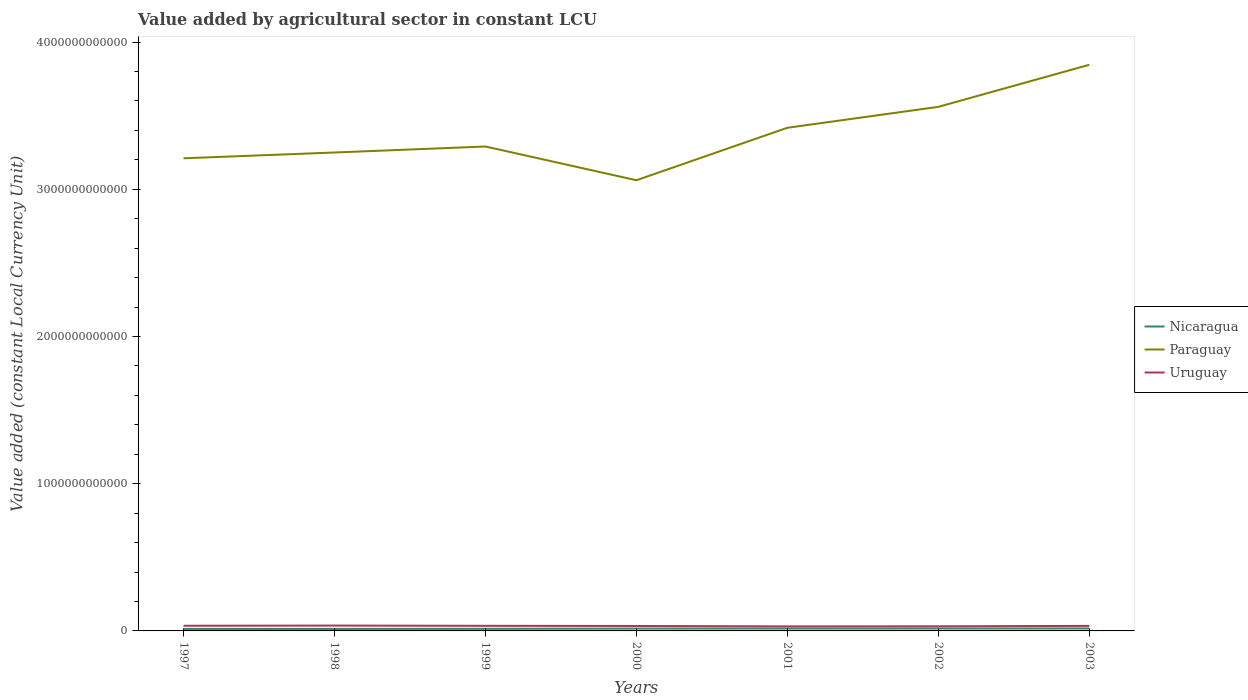How many different coloured lines are there?
Offer a very short reply. 3. Does the line corresponding to Uruguay intersect with the line corresponding to Nicaragua?
Provide a succinct answer. No. Across all years, what is the maximum value added by agricultural sector in Paraguay?
Ensure brevity in your answer.  3.06e+12. In which year was the value added by agricultural sector in Paraguay maximum?
Ensure brevity in your answer.  2000. What is the total value added by agricultural sector in Nicaragua in the graph?
Ensure brevity in your answer.  -3.24e+09. What is the difference between the highest and the second highest value added by agricultural sector in Paraguay?
Offer a terse response. 7.84e+11. How many lines are there?
Give a very brief answer. 3. How many years are there in the graph?
Ensure brevity in your answer.  7. What is the difference between two consecutive major ticks on the Y-axis?
Your answer should be compact. 1.00e+12. Does the graph contain grids?
Your answer should be compact. No. Where does the legend appear in the graph?
Make the answer very short. Center right. What is the title of the graph?
Make the answer very short. Value added by agricultural sector in constant LCU. What is the label or title of the X-axis?
Provide a succinct answer. Years. What is the label or title of the Y-axis?
Your answer should be very brief. Value added (constant Local Currency Unit). What is the Value added (constant Local Currency Unit) of Nicaragua in 1997?
Make the answer very short. 1.35e+1. What is the Value added (constant Local Currency Unit) of Paraguay in 1997?
Offer a very short reply. 3.21e+12. What is the Value added (constant Local Currency Unit) in Uruguay in 1997?
Ensure brevity in your answer.  3.51e+1. What is the Value added (constant Local Currency Unit) in Nicaragua in 1998?
Offer a very short reply. 1.34e+1. What is the Value added (constant Local Currency Unit) in Paraguay in 1998?
Keep it short and to the point. 3.25e+12. What is the Value added (constant Local Currency Unit) in Uruguay in 1998?
Provide a short and direct response. 3.64e+1. What is the Value added (constant Local Currency Unit) in Nicaragua in 1999?
Your answer should be compact. 1.42e+1. What is the Value added (constant Local Currency Unit) in Paraguay in 1999?
Keep it short and to the point. 3.29e+12. What is the Value added (constant Local Currency Unit) of Uruguay in 1999?
Provide a succinct answer. 3.47e+1. What is the Value added (constant Local Currency Unit) of Nicaragua in 2000?
Make the answer very short. 1.60e+1. What is the Value added (constant Local Currency Unit) in Paraguay in 2000?
Keep it short and to the point. 3.06e+12. What is the Value added (constant Local Currency Unit) of Uruguay in 2000?
Give a very brief answer. 3.36e+1. What is the Value added (constant Local Currency Unit) in Nicaragua in 2001?
Your answer should be very brief. 1.64e+1. What is the Value added (constant Local Currency Unit) in Paraguay in 2001?
Give a very brief answer. 3.42e+12. What is the Value added (constant Local Currency Unit) of Uruguay in 2001?
Your answer should be very brief. 3.07e+1. What is the Value added (constant Local Currency Unit) in Nicaragua in 2002?
Your response must be concise. 1.63e+1. What is the Value added (constant Local Currency Unit) in Paraguay in 2002?
Offer a very short reply. 3.56e+12. What is the Value added (constant Local Currency Unit) of Uruguay in 2002?
Your response must be concise. 3.13e+1. What is the Value added (constant Local Currency Unit) of Nicaragua in 2003?
Offer a very short reply. 1.67e+1. What is the Value added (constant Local Currency Unit) in Paraguay in 2003?
Offer a very short reply. 3.85e+12. What is the Value added (constant Local Currency Unit) of Uruguay in 2003?
Give a very brief answer. 3.41e+1. Across all years, what is the maximum Value added (constant Local Currency Unit) of Nicaragua?
Provide a short and direct response. 1.67e+1. Across all years, what is the maximum Value added (constant Local Currency Unit) of Paraguay?
Your answer should be compact. 3.85e+12. Across all years, what is the maximum Value added (constant Local Currency Unit) in Uruguay?
Offer a terse response. 3.64e+1. Across all years, what is the minimum Value added (constant Local Currency Unit) in Nicaragua?
Provide a short and direct response. 1.34e+1. Across all years, what is the minimum Value added (constant Local Currency Unit) in Paraguay?
Your answer should be compact. 3.06e+12. Across all years, what is the minimum Value added (constant Local Currency Unit) in Uruguay?
Make the answer very short. 3.07e+1. What is the total Value added (constant Local Currency Unit) in Nicaragua in the graph?
Offer a very short reply. 1.06e+11. What is the total Value added (constant Local Currency Unit) of Paraguay in the graph?
Keep it short and to the point. 2.36e+13. What is the total Value added (constant Local Currency Unit) in Uruguay in the graph?
Keep it short and to the point. 2.36e+11. What is the difference between the Value added (constant Local Currency Unit) of Nicaragua in 1997 and that in 1998?
Provide a short and direct response. 3.58e+07. What is the difference between the Value added (constant Local Currency Unit) of Paraguay in 1997 and that in 1998?
Make the answer very short. -3.94e+1. What is the difference between the Value added (constant Local Currency Unit) of Uruguay in 1997 and that in 1998?
Give a very brief answer. -1.32e+09. What is the difference between the Value added (constant Local Currency Unit) in Nicaragua in 1997 and that in 1999?
Ensure brevity in your answer.  -7.79e+08. What is the difference between the Value added (constant Local Currency Unit) in Paraguay in 1997 and that in 1999?
Make the answer very short. -8.01e+1. What is the difference between the Value added (constant Local Currency Unit) in Uruguay in 1997 and that in 1999?
Your answer should be very brief. 3.58e+08. What is the difference between the Value added (constant Local Currency Unit) of Nicaragua in 1997 and that in 2000?
Make the answer very short. -2.50e+09. What is the difference between the Value added (constant Local Currency Unit) in Paraguay in 1997 and that in 2000?
Keep it short and to the point. 1.49e+11. What is the difference between the Value added (constant Local Currency Unit) in Uruguay in 1997 and that in 2000?
Give a very brief answer. 1.50e+09. What is the difference between the Value added (constant Local Currency Unit) in Nicaragua in 1997 and that in 2001?
Your answer should be compact. -2.92e+09. What is the difference between the Value added (constant Local Currency Unit) in Paraguay in 1997 and that in 2001?
Your answer should be compact. -2.07e+11. What is the difference between the Value added (constant Local Currency Unit) of Uruguay in 1997 and that in 2001?
Ensure brevity in your answer.  4.37e+09. What is the difference between the Value added (constant Local Currency Unit) in Nicaragua in 1997 and that in 2002?
Offer a terse response. -2.88e+09. What is the difference between the Value added (constant Local Currency Unit) of Paraguay in 1997 and that in 2002?
Your answer should be very brief. -3.49e+11. What is the difference between the Value added (constant Local Currency Unit) in Uruguay in 1997 and that in 2002?
Your answer should be compact. 3.76e+09. What is the difference between the Value added (constant Local Currency Unit) of Nicaragua in 1997 and that in 2003?
Your response must be concise. -3.20e+09. What is the difference between the Value added (constant Local Currency Unit) in Paraguay in 1997 and that in 2003?
Ensure brevity in your answer.  -6.35e+11. What is the difference between the Value added (constant Local Currency Unit) in Uruguay in 1997 and that in 2003?
Your answer should be compact. 9.47e+08. What is the difference between the Value added (constant Local Currency Unit) of Nicaragua in 1998 and that in 1999?
Provide a succinct answer. -8.15e+08. What is the difference between the Value added (constant Local Currency Unit) of Paraguay in 1998 and that in 1999?
Your response must be concise. -4.06e+1. What is the difference between the Value added (constant Local Currency Unit) in Uruguay in 1998 and that in 1999?
Your response must be concise. 1.68e+09. What is the difference between the Value added (constant Local Currency Unit) in Nicaragua in 1998 and that in 2000?
Provide a succinct answer. -2.53e+09. What is the difference between the Value added (constant Local Currency Unit) of Paraguay in 1998 and that in 2000?
Give a very brief answer. 1.88e+11. What is the difference between the Value added (constant Local Currency Unit) of Uruguay in 1998 and that in 2000?
Ensure brevity in your answer.  2.82e+09. What is the difference between the Value added (constant Local Currency Unit) in Nicaragua in 1998 and that in 2001?
Keep it short and to the point. -2.96e+09. What is the difference between the Value added (constant Local Currency Unit) in Paraguay in 1998 and that in 2001?
Your answer should be compact. -1.68e+11. What is the difference between the Value added (constant Local Currency Unit) in Uruguay in 1998 and that in 2001?
Your response must be concise. 5.69e+09. What is the difference between the Value added (constant Local Currency Unit) in Nicaragua in 1998 and that in 2002?
Offer a terse response. -2.92e+09. What is the difference between the Value added (constant Local Currency Unit) in Paraguay in 1998 and that in 2002?
Offer a terse response. -3.10e+11. What is the difference between the Value added (constant Local Currency Unit) of Uruguay in 1998 and that in 2002?
Offer a terse response. 5.08e+09. What is the difference between the Value added (constant Local Currency Unit) in Nicaragua in 1998 and that in 2003?
Make the answer very short. -3.24e+09. What is the difference between the Value added (constant Local Currency Unit) in Paraguay in 1998 and that in 2003?
Give a very brief answer. -5.96e+11. What is the difference between the Value added (constant Local Currency Unit) in Uruguay in 1998 and that in 2003?
Offer a terse response. 2.27e+09. What is the difference between the Value added (constant Local Currency Unit) in Nicaragua in 1999 and that in 2000?
Make the answer very short. -1.72e+09. What is the difference between the Value added (constant Local Currency Unit) of Paraguay in 1999 and that in 2000?
Your answer should be compact. 2.29e+11. What is the difference between the Value added (constant Local Currency Unit) of Uruguay in 1999 and that in 2000?
Offer a very short reply. 1.14e+09. What is the difference between the Value added (constant Local Currency Unit) in Nicaragua in 1999 and that in 2001?
Keep it short and to the point. -2.15e+09. What is the difference between the Value added (constant Local Currency Unit) in Paraguay in 1999 and that in 2001?
Your answer should be very brief. -1.27e+11. What is the difference between the Value added (constant Local Currency Unit) of Uruguay in 1999 and that in 2001?
Offer a terse response. 4.01e+09. What is the difference between the Value added (constant Local Currency Unit) in Nicaragua in 1999 and that in 2002?
Ensure brevity in your answer.  -2.10e+09. What is the difference between the Value added (constant Local Currency Unit) of Paraguay in 1999 and that in 2002?
Ensure brevity in your answer.  -2.69e+11. What is the difference between the Value added (constant Local Currency Unit) in Uruguay in 1999 and that in 2002?
Your response must be concise. 3.40e+09. What is the difference between the Value added (constant Local Currency Unit) in Nicaragua in 1999 and that in 2003?
Provide a short and direct response. -2.42e+09. What is the difference between the Value added (constant Local Currency Unit) in Paraguay in 1999 and that in 2003?
Provide a succinct answer. -5.55e+11. What is the difference between the Value added (constant Local Currency Unit) in Uruguay in 1999 and that in 2003?
Your response must be concise. 5.89e+08. What is the difference between the Value added (constant Local Currency Unit) of Nicaragua in 2000 and that in 2001?
Ensure brevity in your answer.  -4.28e+08. What is the difference between the Value added (constant Local Currency Unit) of Paraguay in 2000 and that in 2001?
Your answer should be very brief. -3.56e+11. What is the difference between the Value added (constant Local Currency Unit) in Uruguay in 2000 and that in 2001?
Provide a short and direct response. 2.87e+09. What is the difference between the Value added (constant Local Currency Unit) in Nicaragua in 2000 and that in 2002?
Offer a terse response. -3.86e+08. What is the difference between the Value added (constant Local Currency Unit) in Paraguay in 2000 and that in 2002?
Offer a terse response. -4.98e+11. What is the difference between the Value added (constant Local Currency Unit) in Uruguay in 2000 and that in 2002?
Provide a succinct answer. 2.26e+09. What is the difference between the Value added (constant Local Currency Unit) of Nicaragua in 2000 and that in 2003?
Your response must be concise. -7.04e+08. What is the difference between the Value added (constant Local Currency Unit) of Paraguay in 2000 and that in 2003?
Make the answer very short. -7.84e+11. What is the difference between the Value added (constant Local Currency Unit) in Uruguay in 2000 and that in 2003?
Your answer should be very brief. -5.48e+08. What is the difference between the Value added (constant Local Currency Unit) of Nicaragua in 2001 and that in 2002?
Your answer should be compact. 4.20e+07. What is the difference between the Value added (constant Local Currency Unit) of Paraguay in 2001 and that in 2002?
Make the answer very short. -1.42e+11. What is the difference between the Value added (constant Local Currency Unit) of Uruguay in 2001 and that in 2002?
Ensure brevity in your answer.  -6.11e+08. What is the difference between the Value added (constant Local Currency Unit) in Nicaragua in 2001 and that in 2003?
Offer a very short reply. -2.76e+08. What is the difference between the Value added (constant Local Currency Unit) of Paraguay in 2001 and that in 2003?
Your answer should be very brief. -4.28e+11. What is the difference between the Value added (constant Local Currency Unit) of Uruguay in 2001 and that in 2003?
Offer a terse response. -3.42e+09. What is the difference between the Value added (constant Local Currency Unit) of Nicaragua in 2002 and that in 2003?
Give a very brief answer. -3.18e+08. What is the difference between the Value added (constant Local Currency Unit) of Paraguay in 2002 and that in 2003?
Keep it short and to the point. -2.86e+11. What is the difference between the Value added (constant Local Currency Unit) in Uruguay in 2002 and that in 2003?
Make the answer very short. -2.81e+09. What is the difference between the Value added (constant Local Currency Unit) of Nicaragua in 1997 and the Value added (constant Local Currency Unit) of Paraguay in 1998?
Your answer should be very brief. -3.24e+12. What is the difference between the Value added (constant Local Currency Unit) of Nicaragua in 1997 and the Value added (constant Local Currency Unit) of Uruguay in 1998?
Make the answer very short. -2.30e+1. What is the difference between the Value added (constant Local Currency Unit) of Paraguay in 1997 and the Value added (constant Local Currency Unit) of Uruguay in 1998?
Offer a terse response. 3.17e+12. What is the difference between the Value added (constant Local Currency Unit) of Nicaragua in 1997 and the Value added (constant Local Currency Unit) of Paraguay in 1999?
Provide a succinct answer. -3.28e+12. What is the difference between the Value added (constant Local Currency Unit) of Nicaragua in 1997 and the Value added (constant Local Currency Unit) of Uruguay in 1999?
Offer a very short reply. -2.13e+1. What is the difference between the Value added (constant Local Currency Unit) of Paraguay in 1997 and the Value added (constant Local Currency Unit) of Uruguay in 1999?
Keep it short and to the point. 3.18e+12. What is the difference between the Value added (constant Local Currency Unit) of Nicaragua in 1997 and the Value added (constant Local Currency Unit) of Paraguay in 2000?
Offer a very short reply. -3.05e+12. What is the difference between the Value added (constant Local Currency Unit) in Nicaragua in 1997 and the Value added (constant Local Currency Unit) in Uruguay in 2000?
Make the answer very short. -2.01e+1. What is the difference between the Value added (constant Local Currency Unit) in Paraguay in 1997 and the Value added (constant Local Currency Unit) in Uruguay in 2000?
Offer a terse response. 3.18e+12. What is the difference between the Value added (constant Local Currency Unit) of Nicaragua in 1997 and the Value added (constant Local Currency Unit) of Paraguay in 2001?
Give a very brief answer. -3.40e+12. What is the difference between the Value added (constant Local Currency Unit) in Nicaragua in 1997 and the Value added (constant Local Currency Unit) in Uruguay in 2001?
Provide a succinct answer. -1.73e+1. What is the difference between the Value added (constant Local Currency Unit) of Paraguay in 1997 and the Value added (constant Local Currency Unit) of Uruguay in 2001?
Provide a short and direct response. 3.18e+12. What is the difference between the Value added (constant Local Currency Unit) in Nicaragua in 1997 and the Value added (constant Local Currency Unit) in Paraguay in 2002?
Provide a succinct answer. -3.55e+12. What is the difference between the Value added (constant Local Currency Unit) in Nicaragua in 1997 and the Value added (constant Local Currency Unit) in Uruguay in 2002?
Your answer should be very brief. -1.79e+1. What is the difference between the Value added (constant Local Currency Unit) of Paraguay in 1997 and the Value added (constant Local Currency Unit) of Uruguay in 2002?
Your answer should be very brief. 3.18e+12. What is the difference between the Value added (constant Local Currency Unit) in Nicaragua in 1997 and the Value added (constant Local Currency Unit) in Paraguay in 2003?
Ensure brevity in your answer.  -3.83e+12. What is the difference between the Value added (constant Local Currency Unit) of Nicaragua in 1997 and the Value added (constant Local Currency Unit) of Uruguay in 2003?
Your response must be concise. -2.07e+1. What is the difference between the Value added (constant Local Currency Unit) in Paraguay in 1997 and the Value added (constant Local Currency Unit) in Uruguay in 2003?
Provide a succinct answer. 3.18e+12. What is the difference between the Value added (constant Local Currency Unit) of Nicaragua in 1998 and the Value added (constant Local Currency Unit) of Paraguay in 1999?
Ensure brevity in your answer.  -3.28e+12. What is the difference between the Value added (constant Local Currency Unit) in Nicaragua in 1998 and the Value added (constant Local Currency Unit) in Uruguay in 1999?
Provide a short and direct response. -2.13e+1. What is the difference between the Value added (constant Local Currency Unit) of Paraguay in 1998 and the Value added (constant Local Currency Unit) of Uruguay in 1999?
Offer a very short reply. 3.21e+12. What is the difference between the Value added (constant Local Currency Unit) of Nicaragua in 1998 and the Value added (constant Local Currency Unit) of Paraguay in 2000?
Provide a succinct answer. -3.05e+12. What is the difference between the Value added (constant Local Currency Unit) in Nicaragua in 1998 and the Value added (constant Local Currency Unit) in Uruguay in 2000?
Offer a terse response. -2.02e+1. What is the difference between the Value added (constant Local Currency Unit) of Paraguay in 1998 and the Value added (constant Local Currency Unit) of Uruguay in 2000?
Make the answer very short. 3.22e+12. What is the difference between the Value added (constant Local Currency Unit) in Nicaragua in 1998 and the Value added (constant Local Currency Unit) in Paraguay in 2001?
Offer a terse response. -3.40e+12. What is the difference between the Value added (constant Local Currency Unit) of Nicaragua in 1998 and the Value added (constant Local Currency Unit) of Uruguay in 2001?
Give a very brief answer. -1.73e+1. What is the difference between the Value added (constant Local Currency Unit) in Paraguay in 1998 and the Value added (constant Local Currency Unit) in Uruguay in 2001?
Give a very brief answer. 3.22e+12. What is the difference between the Value added (constant Local Currency Unit) in Nicaragua in 1998 and the Value added (constant Local Currency Unit) in Paraguay in 2002?
Provide a short and direct response. -3.55e+12. What is the difference between the Value added (constant Local Currency Unit) of Nicaragua in 1998 and the Value added (constant Local Currency Unit) of Uruguay in 2002?
Ensure brevity in your answer.  -1.79e+1. What is the difference between the Value added (constant Local Currency Unit) of Paraguay in 1998 and the Value added (constant Local Currency Unit) of Uruguay in 2002?
Provide a succinct answer. 3.22e+12. What is the difference between the Value added (constant Local Currency Unit) of Nicaragua in 1998 and the Value added (constant Local Currency Unit) of Paraguay in 2003?
Offer a terse response. -3.83e+12. What is the difference between the Value added (constant Local Currency Unit) in Nicaragua in 1998 and the Value added (constant Local Currency Unit) in Uruguay in 2003?
Ensure brevity in your answer.  -2.07e+1. What is the difference between the Value added (constant Local Currency Unit) of Paraguay in 1998 and the Value added (constant Local Currency Unit) of Uruguay in 2003?
Provide a succinct answer. 3.22e+12. What is the difference between the Value added (constant Local Currency Unit) of Nicaragua in 1999 and the Value added (constant Local Currency Unit) of Paraguay in 2000?
Provide a succinct answer. -3.05e+12. What is the difference between the Value added (constant Local Currency Unit) of Nicaragua in 1999 and the Value added (constant Local Currency Unit) of Uruguay in 2000?
Your response must be concise. -1.94e+1. What is the difference between the Value added (constant Local Currency Unit) of Paraguay in 1999 and the Value added (constant Local Currency Unit) of Uruguay in 2000?
Make the answer very short. 3.26e+12. What is the difference between the Value added (constant Local Currency Unit) of Nicaragua in 1999 and the Value added (constant Local Currency Unit) of Paraguay in 2001?
Ensure brevity in your answer.  -3.40e+12. What is the difference between the Value added (constant Local Currency Unit) of Nicaragua in 1999 and the Value added (constant Local Currency Unit) of Uruguay in 2001?
Offer a very short reply. -1.65e+1. What is the difference between the Value added (constant Local Currency Unit) of Paraguay in 1999 and the Value added (constant Local Currency Unit) of Uruguay in 2001?
Ensure brevity in your answer.  3.26e+12. What is the difference between the Value added (constant Local Currency Unit) of Nicaragua in 1999 and the Value added (constant Local Currency Unit) of Paraguay in 2002?
Keep it short and to the point. -3.55e+12. What is the difference between the Value added (constant Local Currency Unit) in Nicaragua in 1999 and the Value added (constant Local Currency Unit) in Uruguay in 2002?
Offer a very short reply. -1.71e+1. What is the difference between the Value added (constant Local Currency Unit) of Paraguay in 1999 and the Value added (constant Local Currency Unit) of Uruguay in 2002?
Your response must be concise. 3.26e+12. What is the difference between the Value added (constant Local Currency Unit) of Nicaragua in 1999 and the Value added (constant Local Currency Unit) of Paraguay in 2003?
Your answer should be very brief. -3.83e+12. What is the difference between the Value added (constant Local Currency Unit) in Nicaragua in 1999 and the Value added (constant Local Currency Unit) in Uruguay in 2003?
Give a very brief answer. -1.99e+1. What is the difference between the Value added (constant Local Currency Unit) of Paraguay in 1999 and the Value added (constant Local Currency Unit) of Uruguay in 2003?
Give a very brief answer. 3.26e+12. What is the difference between the Value added (constant Local Currency Unit) in Nicaragua in 2000 and the Value added (constant Local Currency Unit) in Paraguay in 2001?
Keep it short and to the point. -3.40e+12. What is the difference between the Value added (constant Local Currency Unit) in Nicaragua in 2000 and the Value added (constant Local Currency Unit) in Uruguay in 2001?
Provide a short and direct response. -1.48e+1. What is the difference between the Value added (constant Local Currency Unit) in Paraguay in 2000 and the Value added (constant Local Currency Unit) in Uruguay in 2001?
Provide a short and direct response. 3.03e+12. What is the difference between the Value added (constant Local Currency Unit) of Nicaragua in 2000 and the Value added (constant Local Currency Unit) of Paraguay in 2002?
Ensure brevity in your answer.  -3.54e+12. What is the difference between the Value added (constant Local Currency Unit) in Nicaragua in 2000 and the Value added (constant Local Currency Unit) in Uruguay in 2002?
Make the answer very short. -1.54e+1. What is the difference between the Value added (constant Local Currency Unit) in Paraguay in 2000 and the Value added (constant Local Currency Unit) in Uruguay in 2002?
Ensure brevity in your answer.  3.03e+12. What is the difference between the Value added (constant Local Currency Unit) in Nicaragua in 2000 and the Value added (constant Local Currency Unit) in Paraguay in 2003?
Your response must be concise. -3.83e+12. What is the difference between the Value added (constant Local Currency Unit) in Nicaragua in 2000 and the Value added (constant Local Currency Unit) in Uruguay in 2003?
Your answer should be very brief. -1.82e+1. What is the difference between the Value added (constant Local Currency Unit) in Paraguay in 2000 and the Value added (constant Local Currency Unit) in Uruguay in 2003?
Provide a succinct answer. 3.03e+12. What is the difference between the Value added (constant Local Currency Unit) of Nicaragua in 2001 and the Value added (constant Local Currency Unit) of Paraguay in 2002?
Make the answer very short. -3.54e+12. What is the difference between the Value added (constant Local Currency Unit) in Nicaragua in 2001 and the Value added (constant Local Currency Unit) in Uruguay in 2002?
Provide a short and direct response. -1.50e+1. What is the difference between the Value added (constant Local Currency Unit) in Paraguay in 2001 and the Value added (constant Local Currency Unit) in Uruguay in 2002?
Give a very brief answer. 3.39e+12. What is the difference between the Value added (constant Local Currency Unit) in Nicaragua in 2001 and the Value added (constant Local Currency Unit) in Paraguay in 2003?
Keep it short and to the point. -3.83e+12. What is the difference between the Value added (constant Local Currency Unit) in Nicaragua in 2001 and the Value added (constant Local Currency Unit) in Uruguay in 2003?
Your answer should be very brief. -1.78e+1. What is the difference between the Value added (constant Local Currency Unit) of Paraguay in 2001 and the Value added (constant Local Currency Unit) of Uruguay in 2003?
Offer a terse response. 3.38e+12. What is the difference between the Value added (constant Local Currency Unit) in Nicaragua in 2002 and the Value added (constant Local Currency Unit) in Paraguay in 2003?
Keep it short and to the point. -3.83e+12. What is the difference between the Value added (constant Local Currency Unit) in Nicaragua in 2002 and the Value added (constant Local Currency Unit) in Uruguay in 2003?
Make the answer very short. -1.78e+1. What is the difference between the Value added (constant Local Currency Unit) in Paraguay in 2002 and the Value added (constant Local Currency Unit) in Uruguay in 2003?
Your response must be concise. 3.53e+12. What is the average Value added (constant Local Currency Unit) in Nicaragua per year?
Provide a succinct answer. 1.52e+1. What is the average Value added (constant Local Currency Unit) in Paraguay per year?
Your answer should be compact. 3.38e+12. What is the average Value added (constant Local Currency Unit) of Uruguay per year?
Provide a succinct answer. 3.37e+1. In the year 1997, what is the difference between the Value added (constant Local Currency Unit) of Nicaragua and Value added (constant Local Currency Unit) of Paraguay?
Give a very brief answer. -3.20e+12. In the year 1997, what is the difference between the Value added (constant Local Currency Unit) of Nicaragua and Value added (constant Local Currency Unit) of Uruguay?
Offer a very short reply. -2.16e+1. In the year 1997, what is the difference between the Value added (constant Local Currency Unit) in Paraguay and Value added (constant Local Currency Unit) in Uruguay?
Keep it short and to the point. 3.18e+12. In the year 1998, what is the difference between the Value added (constant Local Currency Unit) in Nicaragua and Value added (constant Local Currency Unit) in Paraguay?
Give a very brief answer. -3.24e+12. In the year 1998, what is the difference between the Value added (constant Local Currency Unit) in Nicaragua and Value added (constant Local Currency Unit) in Uruguay?
Your response must be concise. -2.30e+1. In the year 1998, what is the difference between the Value added (constant Local Currency Unit) of Paraguay and Value added (constant Local Currency Unit) of Uruguay?
Ensure brevity in your answer.  3.21e+12. In the year 1999, what is the difference between the Value added (constant Local Currency Unit) in Nicaragua and Value added (constant Local Currency Unit) in Paraguay?
Make the answer very short. -3.28e+12. In the year 1999, what is the difference between the Value added (constant Local Currency Unit) of Nicaragua and Value added (constant Local Currency Unit) of Uruguay?
Provide a short and direct response. -2.05e+1. In the year 1999, what is the difference between the Value added (constant Local Currency Unit) in Paraguay and Value added (constant Local Currency Unit) in Uruguay?
Offer a very short reply. 3.26e+12. In the year 2000, what is the difference between the Value added (constant Local Currency Unit) in Nicaragua and Value added (constant Local Currency Unit) in Paraguay?
Provide a short and direct response. -3.05e+12. In the year 2000, what is the difference between the Value added (constant Local Currency Unit) of Nicaragua and Value added (constant Local Currency Unit) of Uruguay?
Make the answer very short. -1.76e+1. In the year 2000, what is the difference between the Value added (constant Local Currency Unit) of Paraguay and Value added (constant Local Currency Unit) of Uruguay?
Your answer should be very brief. 3.03e+12. In the year 2001, what is the difference between the Value added (constant Local Currency Unit) of Nicaragua and Value added (constant Local Currency Unit) of Paraguay?
Keep it short and to the point. -3.40e+12. In the year 2001, what is the difference between the Value added (constant Local Currency Unit) of Nicaragua and Value added (constant Local Currency Unit) of Uruguay?
Ensure brevity in your answer.  -1.43e+1. In the year 2001, what is the difference between the Value added (constant Local Currency Unit) of Paraguay and Value added (constant Local Currency Unit) of Uruguay?
Ensure brevity in your answer.  3.39e+12. In the year 2002, what is the difference between the Value added (constant Local Currency Unit) in Nicaragua and Value added (constant Local Currency Unit) in Paraguay?
Offer a very short reply. -3.54e+12. In the year 2002, what is the difference between the Value added (constant Local Currency Unit) of Nicaragua and Value added (constant Local Currency Unit) of Uruguay?
Ensure brevity in your answer.  -1.50e+1. In the year 2002, what is the difference between the Value added (constant Local Currency Unit) in Paraguay and Value added (constant Local Currency Unit) in Uruguay?
Offer a very short reply. 3.53e+12. In the year 2003, what is the difference between the Value added (constant Local Currency Unit) in Nicaragua and Value added (constant Local Currency Unit) in Paraguay?
Give a very brief answer. -3.83e+12. In the year 2003, what is the difference between the Value added (constant Local Currency Unit) in Nicaragua and Value added (constant Local Currency Unit) in Uruguay?
Ensure brevity in your answer.  -1.75e+1. In the year 2003, what is the difference between the Value added (constant Local Currency Unit) of Paraguay and Value added (constant Local Currency Unit) of Uruguay?
Your response must be concise. 3.81e+12. What is the ratio of the Value added (constant Local Currency Unit) of Paraguay in 1997 to that in 1998?
Ensure brevity in your answer.  0.99. What is the ratio of the Value added (constant Local Currency Unit) in Uruguay in 1997 to that in 1998?
Keep it short and to the point. 0.96. What is the ratio of the Value added (constant Local Currency Unit) of Nicaragua in 1997 to that in 1999?
Your answer should be very brief. 0.95. What is the ratio of the Value added (constant Local Currency Unit) in Paraguay in 1997 to that in 1999?
Your answer should be compact. 0.98. What is the ratio of the Value added (constant Local Currency Unit) in Uruguay in 1997 to that in 1999?
Make the answer very short. 1.01. What is the ratio of the Value added (constant Local Currency Unit) of Nicaragua in 1997 to that in 2000?
Provide a short and direct response. 0.84. What is the ratio of the Value added (constant Local Currency Unit) in Paraguay in 1997 to that in 2000?
Make the answer very short. 1.05. What is the ratio of the Value added (constant Local Currency Unit) of Uruguay in 1997 to that in 2000?
Give a very brief answer. 1.04. What is the ratio of the Value added (constant Local Currency Unit) in Nicaragua in 1997 to that in 2001?
Provide a short and direct response. 0.82. What is the ratio of the Value added (constant Local Currency Unit) of Paraguay in 1997 to that in 2001?
Provide a succinct answer. 0.94. What is the ratio of the Value added (constant Local Currency Unit) of Uruguay in 1997 to that in 2001?
Ensure brevity in your answer.  1.14. What is the ratio of the Value added (constant Local Currency Unit) of Nicaragua in 1997 to that in 2002?
Your answer should be compact. 0.82. What is the ratio of the Value added (constant Local Currency Unit) of Paraguay in 1997 to that in 2002?
Your answer should be compact. 0.9. What is the ratio of the Value added (constant Local Currency Unit) in Uruguay in 1997 to that in 2002?
Offer a terse response. 1.12. What is the ratio of the Value added (constant Local Currency Unit) in Nicaragua in 1997 to that in 2003?
Keep it short and to the point. 0.81. What is the ratio of the Value added (constant Local Currency Unit) of Paraguay in 1997 to that in 2003?
Ensure brevity in your answer.  0.83. What is the ratio of the Value added (constant Local Currency Unit) in Uruguay in 1997 to that in 2003?
Make the answer very short. 1.03. What is the ratio of the Value added (constant Local Currency Unit) of Nicaragua in 1998 to that in 1999?
Make the answer very short. 0.94. What is the ratio of the Value added (constant Local Currency Unit) in Uruguay in 1998 to that in 1999?
Your answer should be very brief. 1.05. What is the ratio of the Value added (constant Local Currency Unit) in Nicaragua in 1998 to that in 2000?
Give a very brief answer. 0.84. What is the ratio of the Value added (constant Local Currency Unit) of Paraguay in 1998 to that in 2000?
Keep it short and to the point. 1.06. What is the ratio of the Value added (constant Local Currency Unit) in Uruguay in 1998 to that in 2000?
Your response must be concise. 1.08. What is the ratio of the Value added (constant Local Currency Unit) in Nicaragua in 1998 to that in 2001?
Offer a very short reply. 0.82. What is the ratio of the Value added (constant Local Currency Unit) in Paraguay in 1998 to that in 2001?
Provide a succinct answer. 0.95. What is the ratio of the Value added (constant Local Currency Unit) in Uruguay in 1998 to that in 2001?
Make the answer very short. 1.19. What is the ratio of the Value added (constant Local Currency Unit) in Nicaragua in 1998 to that in 2002?
Your response must be concise. 0.82. What is the ratio of the Value added (constant Local Currency Unit) in Paraguay in 1998 to that in 2002?
Your answer should be compact. 0.91. What is the ratio of the Value added (constant Local Currency Unit) in Uruguay in 1998 to that in 2002?
Offer a terse response. 1.16. What is the ratio of the Value added (constant Local Currency Unit) of Nicaragua in 1998 to that in 2003?
Provide a short and direct response. 0.81. What is the ratio of the Value added (constant Local Currency Unit) of Paraguay in 1998 to that in 2003?
Your answer should be compact. 0.85. What is the ratio of the Value added (constant Local Currency Unit) of Uruguay in 1998 to that in 2003?
Keep it short and to the point. 1.07. What is the ratio of the Value added (constant Local Currency Unit) of Nicaragua in 1999 to that in 2000?
Provide a succinct answer. 0.89. What is the ratio of the Value added (constant Local Currency Unit) of Paraguay in 1999 to that in 2000?
Provide a short and direct response. 1.07. What is the ratio of the Value added (constant Local Currency Unit) in Uruguay in 1999 to that in 2000?
Keep it short and to the point. 1.03. What is the ratio of the Value added (constant Local Currency Unit) in Nicaragua in 1999 to that in 2001?
Provide a succinct answer. 0.87. What is the ratio of the Value added (constant Local Currency Unit) of Paraguay in 1999 to that in 2001?
Your answer should be compact. 0.96. What is the ratio of the Value added (constant Local Currency Unit) in Uruguay in 1999 to that in 2001?
Ensure brevity in your answer.  1.13. What is the ratio of the Value added (constant Local Currency Unit) in Nicaragua in 1999 to that in 2002?
Your answer should be very brief. 0.87. What is the ratio of the Value added (constant Local Currency Unit) in Paraguay in 1999 to that in 2002?
Ensure brevity in your answer.  0.92. What is the ratio of the Value added (constant Local Currency Unit) in Uruguay in 1999 to that in 2002?
Give a very brief answer. 1.11. What is the ratio of the Value added (constant Local Currency Unit) in Nicaragua in 1999 to that in 2003?
Your response must be concise. 0.85. What is the ratio of the Value added (constant Local Currency Unit) of Paraguay in 1999 to that in 2003?
Make the answer very short. 0.86. What is the ratio of the Value added (constant Local Currency Unit) of Uruguay in 1999 to that in 2003?
Provide a short and direct response. 1.02. What is the ratio of the Value added (constant Local Currency Unit) of Nicaragua in 2000 to that in 2001?
Your response must be concise. 0.97. What is the ratio of the Value added (constant Local Currency Unit) in Paraguay in 2000 to that in 2001?
Provide a succinct answer. 0.9. What is the ratio of the Value added (constant Local Currency Unit) in Uruguay in 2000 to that in 2001?
Give a very brief answer. 1.09. What is the ratio of the Value added (constant Local Currency Unit) in Nicaragua in 2000 to that in 2002?
Offer a terse response. 0.98. What is the ratio of the Value added (constant Local Currency Unit) of Paraguay in 2000 to that in 2002?
Your response must be concise. 0.86. What is the ratio of the Value added (constant Local Currency Unit) of Uruguay in 2000 to that in 2002?
Make the answer very short. 1.07. What is the ratio of the Value added (constant Local Currency Unit) in Nicaragua in 2000 to that in 2003?
Provide a short and direct response. 0.96. What is the ratio of the Value added (constant Local Currency Unit) in Paraguay in 2000 to that in 2003?
Keep it short and to the point. 0.8. What is the ratio of the Value added (constant Local Currency Unit) of Uruguay in 2000 to that in 2003?
Your answer should be compact. 0.98. What is the ratio of the Value added (constant Local Currency Unit) of Nicaragua in 2001 to that in 2002?
Ensure brevity in your answer.  1. What is the ratio of the Value added (constant Local Currency Unit) of Paraguay in 2001 to that in 2002?
Ensure brevity in your answer.  0.96. What is the ratio of the Value added (constant Local Currency Unit) in Uruguay in 2001 to that in 2002?
Provide a short and direct response. 0.98. What is the ratio of the Value added (constant Local Currency Unit) in Nicaragua in 2001 to that in 2003?
Your answer should be very brief. 0.98. What is the ratio of the Value added (constant Local Currency Unit) in Paraguay in 2001 to that in 2003?
Offer a very short reply. 0.89. What is the ratio of the Value added (constant Local Currency Unit) of Uruguay in 2001 to that in 2003?
Your answer should be very brief. 0.9. What is the ratio of the Value added (constant Local Currency Unit) of Nicaragua in 2002 to that in 2003?
Provide a short and direct response. 0.98. What is the ratio of the Value added (constant Local Currency Unit) of Paraguay in 2002 to that in 2003?
Keep it short and to the point. 0.93. What is the ratio of the Value added (constant Local Currency Unit) of Uruguay in 2002 to that in 2003?
Your answer should be compact. 0.92. What is the difference between the highest and the second highest Value added (constant Local Currency Unit) of Nicaragua?
Your answer should be very brief. 2.76e+08. What is the difference between the highest and the second highest Value added (constant Local Currency Unit) of Paraguay?
Your response must be concise. 2.86e+11. What is the difference between the highest and the second highest Value added (constant Local Currency Unit) in Uruguay?
Offer a terse response. 1.32e+09. What is the difference between the highest and the lowest Value added (constant Local Currency Unit) of Nicaragua?
Make the answer very short. 3.24e+09. What is the difference between the highest and the lowest Value added (constant Local Currency Unit) in Paraguay?
Offer a terse response. 7.84e+11. What is the difference between the highest and the lowest Value added (constant Local Currency Unit) in Uruguay?
Your response must be concise. 5.69e+09. 